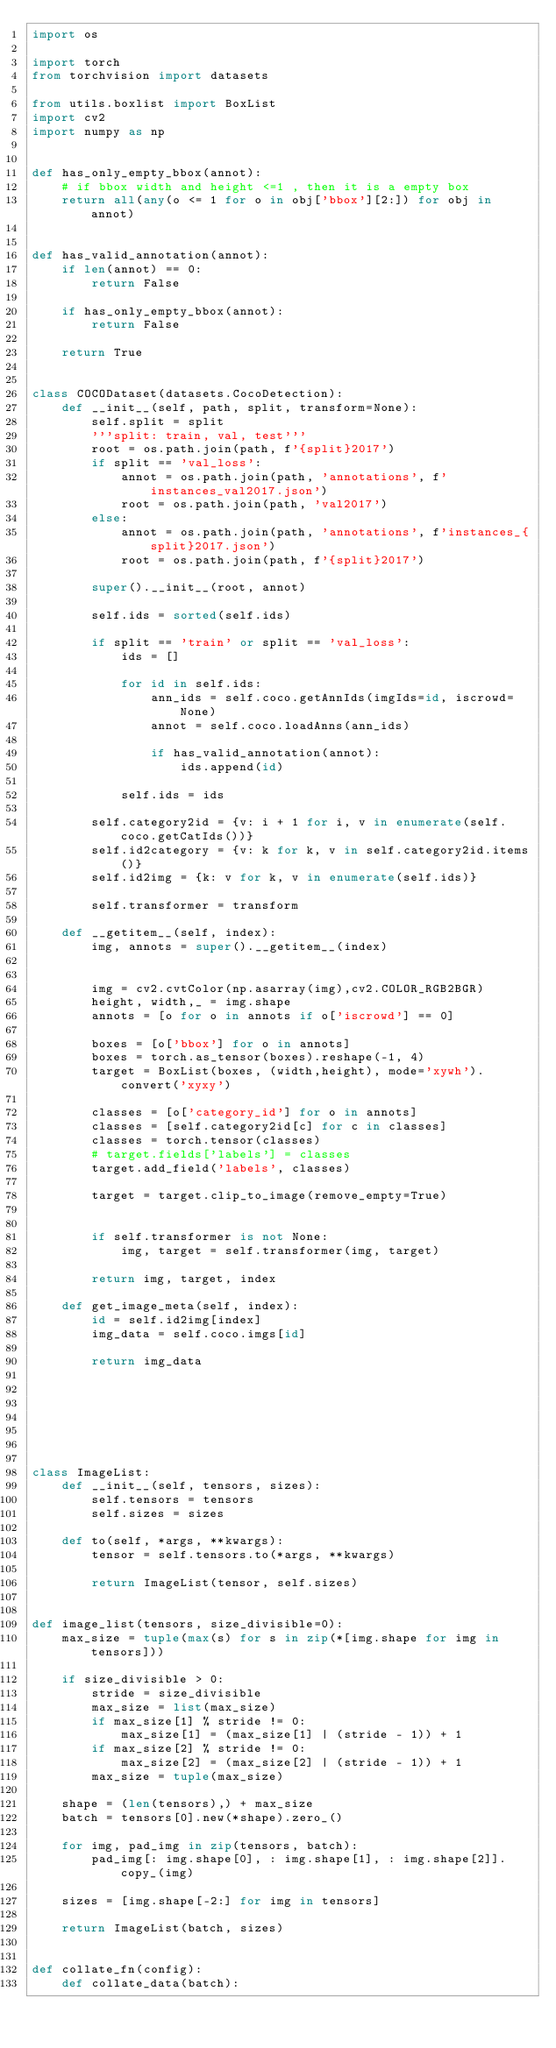<code> <loc_0><loc_0><loc_500><loc_500><_Python_>import os

import torch
from torchvision import datasets

from utils.boxlist import BoxList
import cv2
import numpy as np


def has_only_empty_bbox(annot):
    # if bbox width and height <=1 , then it is a empty box
    return all(any(o <= 1 for o in obj['bbox'][2:]) for obj in annot)


def has_valid_annotation(annot):
    if len(annot) == 0:
        return False

    if has_only_empty_bbox(annot):
        return False

    return True


class COCODataset(datasets.CocoDetection):
    def __init__(self, path, split, transform=None):
        self.split = split
        '''split: train, val, test'''
        root = os.path.join(path, f'{split}2017')
        if split == 'val_loss':
            annot = os.path.join(path, 'annotations', f'instances_val2017.json')
            root = os.path.join(path, 'val2017')
        else:
            annot = os.path.join(path, 'annotations', f'instances_{split}2017.json')
            root = os.path.join(path, f'{split}2017')

        super().__init__(root, annot)

        self.ids = sorted(self.ids)

        if split == 'train' or split == 'val_loss':
            ids = []

            for id in self.ids:
                ann_ids = self.coco.getAnnIds(imgIds=id, iscrowd=None)
                annot = self.coco.loadAnns(ann_ids)

                if has_valid_annotation(annot):
                    ids.append(id)

            self.ids = ids

        self.category2id = {v: i + 1 for i, v in enumerate(self.coco.getCatIds())}
        self.id2category = {v: k for k, v in self.category2id.items()}
        self.id2img = {k: v for k, v in enumerate(self.ids)}

        self.transformer = transform

    def __getitem__(self, index):
        img, annots = super().__getitem__(index)


        img = cv2.cvtColor(np.asarray(img),cv2.COLOR_RGB2BGR)
        height, width,_ = img.shape
        annots = [o for o in annots if o['iscrowd'] == 0]

        boxes = [o['bbox'] for o in annots]
        boxes = torch.as_tensor(boxes).reshape(-1, 4)
        target = BoxList(boxes, (width,height), mode='xywh').convert('xyxy')

        classes = [o['category_id'] for o in annots]
        classes = [self.category2id[c] for c in classes]
        classes = torch.tensor(classes)
        # target.fields['labels'] = classes
        target.add_field('labels', classes)

        target = target.clip_to_image(remove_empty=True)


        if self.transformer is not None:
            img, target = self.transformer(img, target)

        return img, target, index

    def get_image_meta(self, index):
        id = self.id2img[index]
        img_data = self.coco.imgs[id]

        return img_data







class ImageList:
    def __init__(self, tensors, sizes):
        self.tensors = tensors
        self.sizes = sizes

    def to(self, *args, **kwargs):
        tensor = self.tensors.to(*args, **kwargs)

        return ImageList(tensor, self.sizes)


def image_list(tensors, size_divisible=0):
    max_size = tuple(max(s) for s in zip(*[img.shape for img in tensors]))

    if size_divisible > 0:
        stride = size_divisible
        max_size = list(max_size)
        if max_size[1] % stride != 0:
            max_size[1] = (max_size[1] | (stride - 1)) + 1
        if max_size[2] % stride != 0:
            max_size[2] = (max_size[2] | (stride - 1)) + 1
        max_size = tuple(max_size)

    shape = (len(tensors),) + max_size
    batch = tensors[0].new(*shape).zero_()

    for img, pad_img in zip(tensors, batch):
        pad_img[: img.shape[0], : img.shape[1], : img.shape[2]].copy_(img)

    sizes = [img.shape[-2:] for img in tensors]

    return ImageList(batch, sizes)


def collate_fn(config):
    def collate_data(batch):</code> 